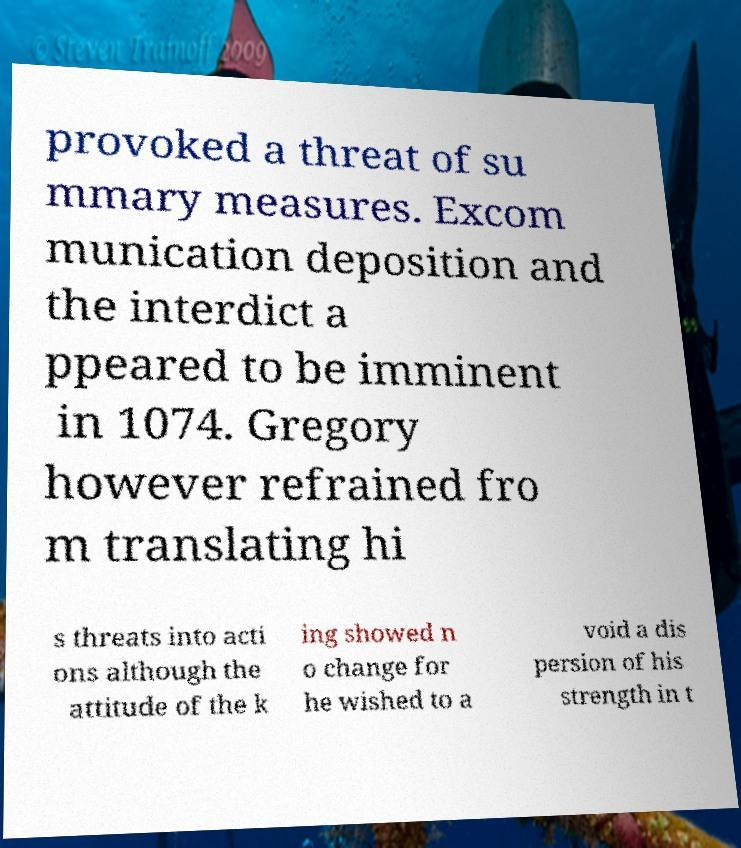Could you extract and type out the text from this image? provoked a threat of su mmary measures. Excom munication deposition and the interdict a ppeared to be imminent in 1074. Gregory however refrained fro m translating hi s threats into acti ons although the attitude of the k ing showed n o change for he wished to a void a dis persion of his strength in t 